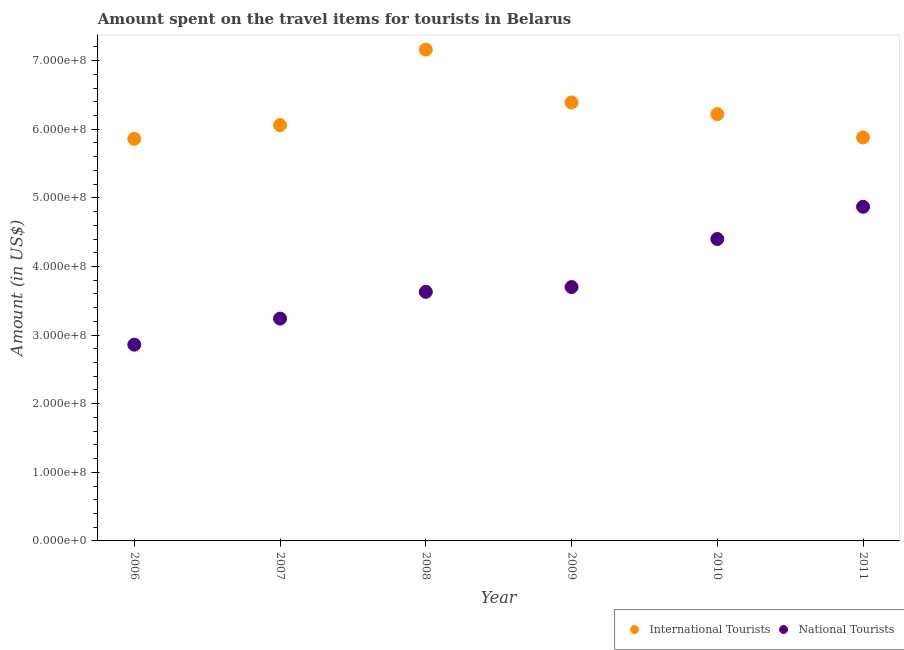Is the number of dotlines equal to the number of legend labels?
Provide a short and direct response. Yes. What is the amount spent on travel items of national tourists in 2008?
Your answer should be very brief. 3.63e+08. Across all years, what is the maximum amount spent on travel items of international tourists?
Your answer should be compact. 7.16e+08. Across all years, what is the minimum amount spent on travel items of national tourists?
Ensure brevity in your answer.  2.86e+08. In which year was the amount spent on travel items of national tourists maximum?
Keep it short and to the point. 2011. In which year was the amount spent on travel items of national tourists minimum?
Provide a short and direct response. 2006. What is the total amount spent on travel items of national tourists in the graph?
Provide a short and direct response. 2.27e+09. What is the difference between the amount spent on travel items of international tourists in 2008 and that in 2009?
Offer a terse response. 7.70e+07. What is the difference between the amount spent on travel items of international tourists in 2010 and the amount spent on travel items of national tourists in 2008?
Your response must be concise. 2.59e+08. What is the average amount spent on travel items of international tourists per year?
Give a very brief answer. 6.26e+08. In the year 2011, what is the difference between the amount spent on travel items of national tourists and amount spent on travel items of international tourists?
Offer a terse response. -1.01e+08. In how many years, is the amount spent on travel items of international tourists greater than 620000000 US$?
Keep it short and to the point. 3. What is the ratio of the amount spent on travel items of national tourists in 2007 to that in 2009?
Your answer should be very brief. 0.88. What is the difference between the highest and the second highest amount spent on travel items of international tourists?
Your response must be concise. 7.70e+07. What is the difference between the highest and the lowest amount spent on travel items of national tourists?
Your answer should be very brief. 2.01e+08. Is the sum of the amount spent on travel items of national tourists in 2008 and 2010 greater than the maximum amount spent on travel items of international tourists across all years?
Keep it short and to the point. Yes. Is the amount spent on travel items of national tourists strictly greater than the amount spent on travel items of international tourists over the years?
Provide a short and direct response. No. Is the amount spent on travel items of national tourists strictly less than the amount spent on travel items of international tourists over the years?
Offer a terse response. Yes. How many years are there in the graph?
Keep it short and to the point. 6. What is the difference between two consecutive major ticks on the Y-axis?
Offer a terse response. 1.00e+08. Are the values on the major ticks of Y-axis written in scientific E-notation?
Offer a terse response. Yes. Where does the legend appear in the graph?
Your answer should be very brief. Bottom right. How many legend labels are there?
Give a very brief answer. 2. How are the legend labels stacked?
Ensure brevity in your answer.  Horizontal. What is the title of the graph?
Keep it short and to the point. Amount spent on the travel items for tourists in Belarus. Does "Current education expenditure" appear as one of the legend labels in the graph?
Your response must be concise. No. What is the label or title of the X-axis?
Your answer should be very brief. Year. What is the Amount (in US$) in International Tourists in 2006?
Provide a short and direct response. 5.86e+08. What is the Amount (in US$) in National Tourists in 2006?
Offer a very short reply. 2.86e+08. What is the Amount (in US$) of International Tourists in 2007?
Make the answer very short. 6.06e+08. What is the Amount (in US$) of National Tourists in 2007?
Make the answer very short. 3.24e+08. What is the Amount (in US$) in International Tourists in 2008?
Offer a very short reply. 7.16e+08. What is the Amount (in US$) in National Tourists in 2008?
Make the answer very short. 3.63e+08. What is the Amount (in US$) of International Tourists in 2009?
Give a very brief answer. 6.39e+08. What is the Amount (in US$) of National Tourists in 2009?
Make the answer very short. 3.70e+08. What is the Amount (in US$) of International Tourists in 2010?
Your answer should be compact. 6.22e+08. What is the Amount (in US$) of National Tourists in 2010?
Offer a terse response. 4.40e+08. What is the Amount (in US$) in International Tourists in 2011?
Make the answer very short. 5.88e+08. What is the Amount (in US$) in National Tourists in 2011?
Make the answer very short. 4.87e+08. Across all years, what is the maximum Amount (in US$) in International Tourists?
Provide a succinct answer. 7.16e+08. Across all years, what is the maximum Amount (in US$) of National Tourists?
Your response must be concise. 4.87e+08. Across all years, what is the minimum Amount (in US$) in International Tourists?
Provide a short and direct response. 5.86e+08. Across all years, what is the minimum Amount (in US$) of National Tourists?
Provide a short and direct response. 2.86e+08. What is the total Amount (in US$) in International Tourists in the graph?
Offer a very short reply. 3.76e+09. What is the total Amount (in US$) in National Tourists in the graph?
Make the answer very short. 2.27e+09. What is the difference between the Amount (in US$) in International Tourists in 2006 and that in 2007?
Ensure brevity in your answer.  -2.00e+07. What is the difference between the Amount (in US$) of National Tourists in 2006 and that in 2007?
Ensure brevity in your answer.  -3.80e+07. What is the difference between the Amount (in US$) of International Tourists in 2006 and that in 2008?
Ensure brevity in your answer.  -1.30e+08. What is the difference between the Amount (in US$) of National Tourists in 2006 and that in 2008?
Ensure brevity in your answer.  -7.70e+07. What is the difference between the Amount (in US$) in International Tourists in 2006 and that in 2009?
Offer a very short reply. -5.30e+07. What is the difference between the Amount (in US$) of National Tourists in 2006 and that in 2009?
Provide a short and direct response. -8.40e+07. What is the difference between the Amount (in US$) of International Tourists in 2006 and that in 2010?
Your answer should be very brief. -3.60e+07. What is the difference between the Amount (in US$) in National Tourists in 2006 and that in 2010?
Your answer should be very brief. -1.54e+08. What is the difference between the Amount (in US$) in National Tourists in 2006 and that in 2011?
Your answer should be very brief. -2.01e+08. What is the difference between the Amount (in US$) of International Tourists in 2007 and that in 2008?
Give a very brief answer. -1.10e+08. What is the difference between the Amount (in US$) of National Tourists in 2007 and that in 2008?
Offer a terse response. -3.90e+07. What is the difference between the Amount (in US$) in International Tourists in 2007 and that in 2009?
Offer a very short reply. -3.30e+07. What is the difference between the Amount (in US$) of National Tourists in 2007 and that in 2009?
Your answer should be compact. -4.60e+07. What is the difference between the Amount (in US$) in International Tourists in 2007 and that in 2010?
Keep it short and to the point. -1.60e+07. What is the difference between the Amount (in US$) in National Tourists in 2007 and that in 2010?
Your answer should be very brief. -1.16e+08. What is the difference between the Amount (in US$) of International Tourists in 2007 and that in 2011?
Your answer should be very brief. 1.80e+07. What is the difference between the Amount (in US$) in National Tourists in 2007 and that in 2011?
Keep it short and to the point. -1.63e+08. What is the difference between the Amount (in US$) of International Tourists in 2008 and that in 2009?
Provide a short and direct response. 7.70e+07. What is the difference between the Amount (in US$) in National Tourists in 2008 and that in 2009?
Provide a succinct answer. -7.00e+06. What is the difference between the Amount (in US$) in International Tourists in 2008 and that in 2010?
Your answer should be compact. 9.40e+07. What is the difference between the Amount (in US$) in National Tourists in 2008 and that in 2010?
Give a very brief answer. -7.70e+07. What is the difference between the Amount (in US$) in International Tourists in 2008 and that in 2011?
Your answer should be compact. 1.28e+08. What is the difference between the Amount (in US$) of National Tourists in 2008 and that in 2011?
Your response must be concise. -1.24e+08. What is the difference between the Amount (in US$) in International Tourists in 2009 and that in 2010?
Provide a short and direct response. 1.70e+07. What is the difference between the Amount (in US$) of National Tourists in 2009 and that in 2010?
Offer a terse response. -7.00e+07. What is the difference between the Amount (in US$) in International Tourists in 2009 and that in 2011?
Ensure brevity in your answer.  5.10e+07. What is the difference between the Amount (in US$) in National Tourists in 2009 and that in 2011?
Give a very brief answer. -1.17e+08. What is the difference between the Amount (in US$) in International Tourists in 2010 and that in 2011?
Your response must be concise. 3.40e+07. What is the difference between the Amount (in US$) of National Tourists in 2010 and that in 2011?
Provide a succinct answer. -4.70e+07. What is the difference between the Amount (in US$) of International Tourists in 2006 and the Amount (in US$) of National Tourists in 2007?
Your answer should be very brief. 2.62e+08. What is the difference between the Amount (in US$) of International Tourists in 2006 and the Amount (in US$) of National Tourists in 2008?
Keep it short and to the point. 2.23e+08. What is the difference between the Amount (in US$) in International Tourists in 2006 and the Amount (in US$) in National Tourists in 2009?
Ensure brevity in your answer.  2.16e+08. What is the difference between the Amount (in US$) in International Tourists in 2006 and the Amount (in US$) in National Tourists in 2010?
Offer a terse response. 1.46e+08. What is the difference between the Amount (in US$) in International Tourists in 2006 and the Amount (in US$) in National Tourists in 2011?
Your answer should be very brief. 9.90e+07. What is the difference between the Amount (in US$) of International Tourists in 2007 and the Amount (in US$) of National Tourists in 2008?
Your answer should be compact. 2.43e+08. What is the difference between the Amount (in US$) of International Tourists in 2007 and the Amount (in US$) of National Tourists in 2009?
Provide a succinct answer. 2.36e+08. What is the difference between the Amount (in US$) in International Tourists in 2007 and the Amount (in US$) in National Tourists in 2010?
Make the answer very short. 1.66e+08. What is the difference between the Amount (in US$) of International Tourists in 2007 and the Amount (in US$) of National Tourists in 2011?
Give a very brief answer. 1.19e+08. What is the difference between the Amount (in US$) in International Tourists in 2008 and the Amount (in US$) in National Tourists in 2009?
Offer a terse response. 3.46e+08. What is the difference between the Amount (in US$) of International Tourists in 2008 and the Amount (in US$) of National Tourists in 2010?
Your answer should be compact. 2.76e+08. What is the difference between the Amount (in US$) of International Tourists in 2008 and the Amount (in US$) of National Tourists in 2011?
Give a very brief answer. 2.29e+08. What is the difference between the Amount (in US$) in International Tourists in 2009 and the Amount (in US$) in National Tourists in 2010?
Your answer should be very brief. 1.99e+08. What is the difference between the Amount (in US$) in International Tourists in 2009 and the Amount (in US$) in National Tourists in 2011?
Provide a succinct answer. 1.52e+08. What is the difference between the Amount (in US$) in International Tourists in 2010 and the Amount (in US$) in National Tourists in 2011?
Provide a succinct answer. 1.35e+08. What is the average Amount (in US$) in International Tourists per year?
Provide a succinct answer. 6.26e+08. What is the average Amount (in US$) in National Tourists per year?
Offer a terse response. 3.78e+08. In the year 2006, what is the difference between the Amount (in US$) in International Tourists and Amount (in US$) in National Tourists?
Offer a terse response. 3.00e+08. In the year 2007, what is the difference between the Amount (in US$) in International Tourists and Amount (in US$) in National Tourists?
Ensure brevity in your answer.  2.82e+08. In the year 2008, what is the difference between the Amount (in US$) in International Tourists and Amount (in US$) in National Tourists?
Your answer should be very brief. 3.53e+08. In the year 2009, what is the difference between the Amount (in US$) in International Tourists and Amount (in US$) in National Tourists?
Your answer should be compact. 2.69e+08. In the year 2010, what is the difference between the Amount (in US$) in International Tourists and Amount (in US$) in National Tourists?
Offer a very short reply. 1.82e+08. In the year 2011, what is the difference between the Amount (in US$) of International Tourists and Amount (in US$) of National Tourists?
Give a very brief answer. 1.01e+08. What is the ratio of the Amount (in US$) of International Tourists in 2006 to that in 2007?
Provide a short and direct response. 0.97. What is the ratio of the Amount (in US$) in National Tourists in 2006 to that in 2007?
Offer a very short reply. 0.88. What is the ratio of the Amount (in US$) in International Tourists in 2006 to that in 2008?
Offer a terse response. 0.82. What is the ratio of the Amount (in US$) of National Tourists in 2006 to that in 2008?
Give a very brief answer. 0.79. What is the ratio of the Amount (in US$) of International Tourists in 2006 to that in 2009?
Provide a succinct answer. 0.92. What is the ratio of the Amount (in US$) in National Tourists in 2006 to that in 2009?
Your response must be concise. 0.77. What is the ratio of the Amount (in US$) in International Tourists in 2006 to that in 2010?
Provide a succinct answer. 0.94. What is the ratio of the Amount (in US$) of National Tourists in 2006 to that in 2010?
Your answer should be very brief. 0.65. What is the ratio of the Amount (in US$) of National Tourists in 2006 to that in 2011?
Provide a succinct answer. 0.59. What is the ratio of the Amount (in US$) of International Tourists in 2007 to that in 2008?
Make the answer very short. 0.85. What is the ratio of the Amount (in US$) of National Tourists in 2007 to that in 2008?
Offer a terse response. 0.89. What is the ratio of the Amount (in US$) of International Tourists in 2007 to that in 2009?
Your answer should be very brief. 0.95. What is the ratio of the Amount (in US$) in National Tourists in 2007 to that in 2009?
Ensure brevity in your answer.  0.88. What is the ratio of the Amount (in US$) in International Tourists in 2007 to that in 2010?
Provide a succinct answer. 0.97. What is the ratio of the Amount (in US$) in National Tourists in 2007 to that in 2010?
Make the answer very short. 0.74. What is the ratio of the Amount (in US$) in International Tourists in 2007 to that in 2011?
Offer a very short reply. 1.03. What is the ratio of the Amount (in US$) in National Tourists in 2007 to that in 2011?
Offer a terse response. 0.67. What is the ratio of the Amount (in US$) in International Tourists in 2008 to that in 2009?
Give a very brief answer. 1.12. What is the ratio of the Amount (in US$) in National Tourists in 2008 to that in 2009?
Provide a short and direct response. 0.98. What is the ratio of the Amount (in US$) in International Tourists in 2008 to that in 2010?
Ensure brevity in your answer.  1.15. What is the ratio of the Amount (in US$) of National Tourists in 2008 to that in 2010?
Give a very brief answer. 0.82. What is the ratio of the Amount (in US$) in International Tourists in 2008 to that in 2011?
Offer a very short reply. 1.22. What is the ratio of the Amount (in US$) in National Tourists in 2008 to that in 2011?
Your response must be concise. 0.75. What is the ratio of the Amount (in US$) of International Tourists in 2009 to that in 2010?
Provide a short and direct response. 1.03. What is the ratio of the Amount (in US$) of National Tourists in 2009 to that in 2010?
Ensure brevity in your answer.  0.84. What is the ratio of the Amount (in US$) of International Tourists in 2009 to that in 2011?
Make the answer very short. 1.09. What is the ratio of the Amount (in US$) in National Tourists in 2009 to that in 2011?
Offer a very short reply. 0.76. What is the ratio of the Amount (in US$) of International Tourists in 2010 to that in 2011?
Keep it short and to the point. 1.06. What is the ratio of the Amount (in US$) of National Tourists in 2010 to that in 2011?
Offer a very short reply. 0.9. What is the difference between the highest and the second highest Amount (in US$) in International Tourists?
Offer a terse response. 7.70e+07. What is the difference between the highest and the second highest Amount (in US$) in National Tourists?
Ensure brevity in your answer.  4.70e+07. What is the difference between the highest and the lowest Amount (in US$) of International Tourists?
Your answer should be compact. 1.30e+08. What is the difference between the highest and the lowest Amount (in US$) in National Tourists?
Your answer should be very brief. 2.01e+08. 